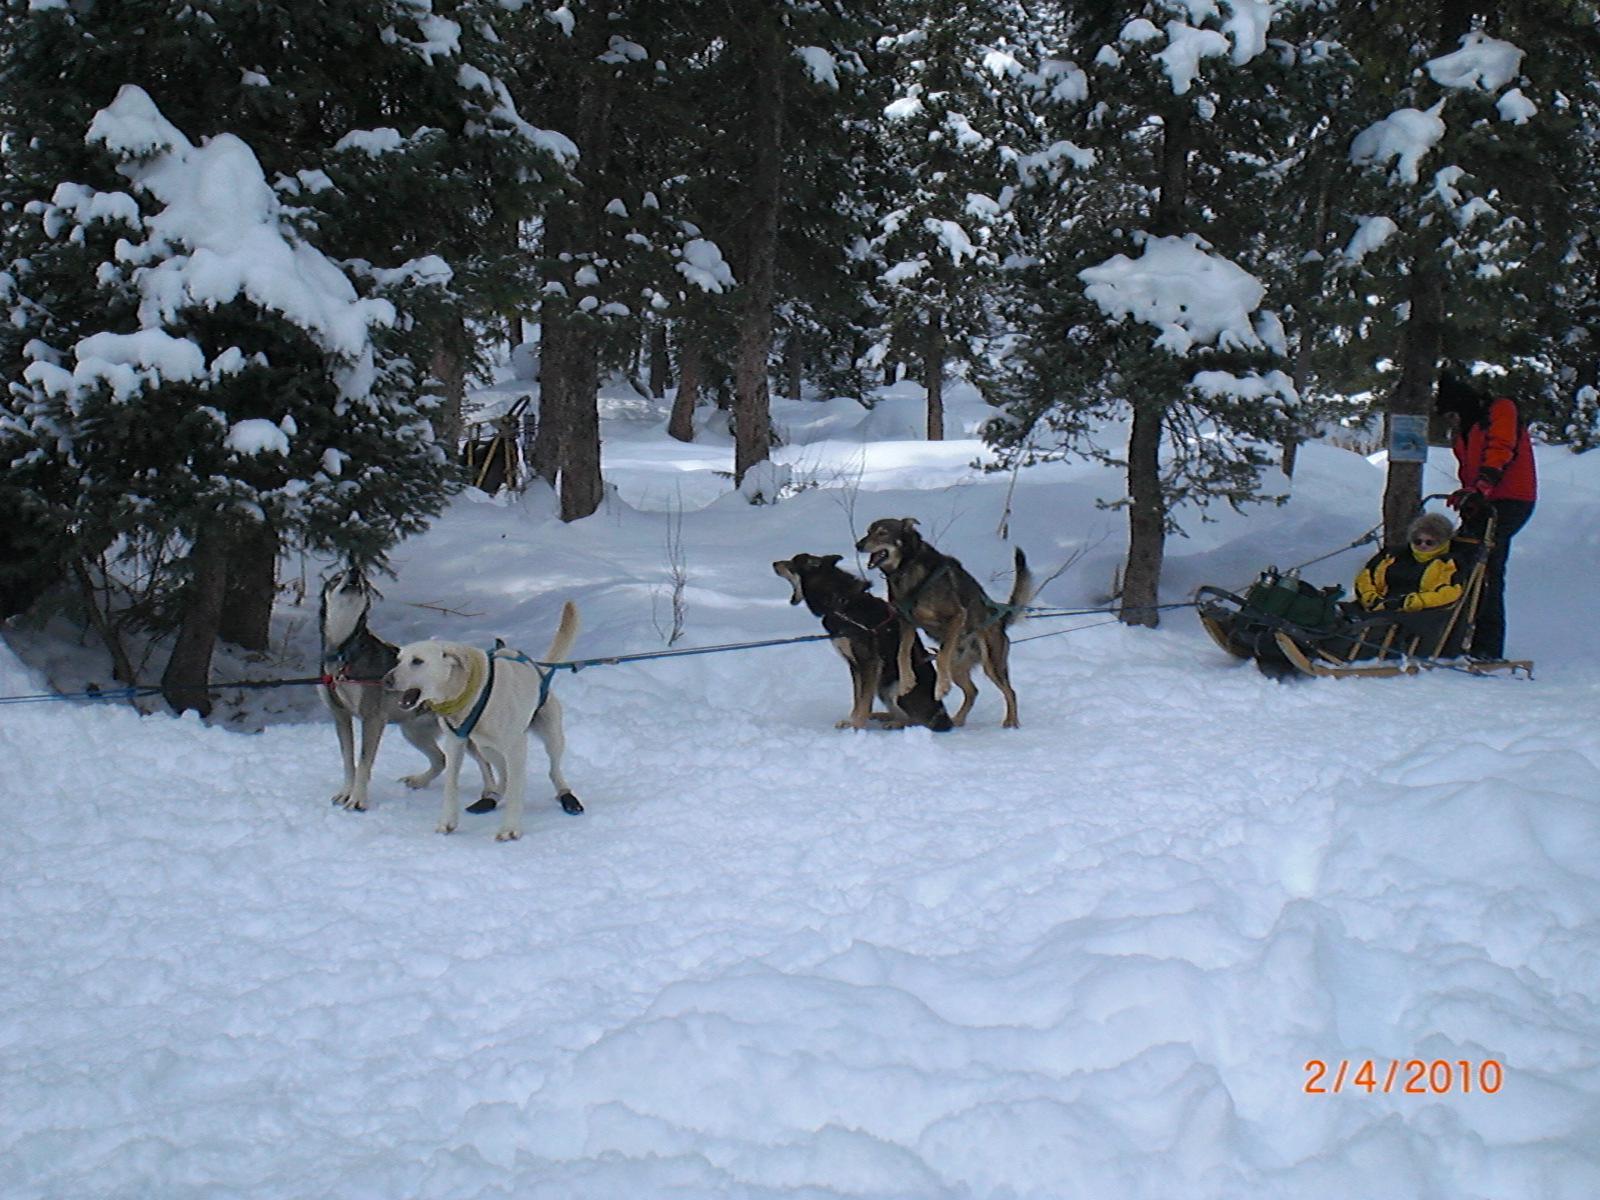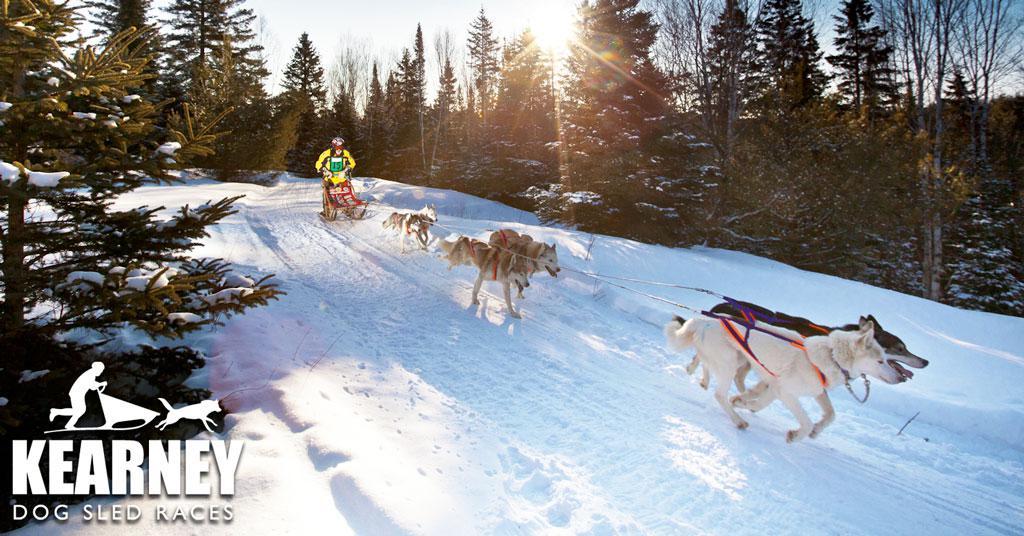The first image is the image on the left, the second image is the image on the right. Considering the images on both sides, is "The dog team in the right image is moving away from the camera, and the dog team on the left is also moving, but not away from the camera." valid? Answer yes or no. No. The first image is the image on the left, the second image is the image on the right. Analyze the images presented: Is the assertion "All the dogs are moving forward." valid? Answer yes or no. No. 